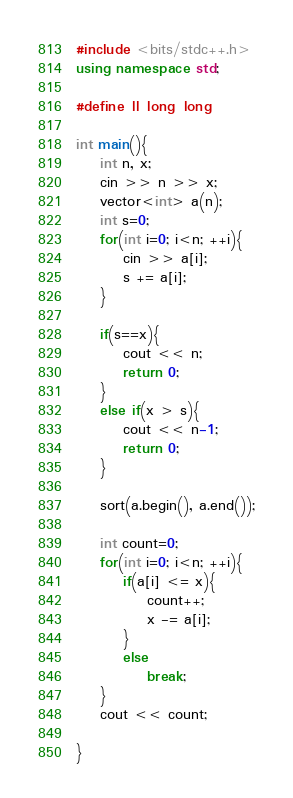Convert code to text. <code><loc_0><loc_0><loc_500><loc_500><_C++_>#include <bits/stdc++.h>
using namespace std;

#define ll long long

int main(){
    int n, x;
    cin >> n >> x;
    vector<int> a(n);
    int s=0;
    for(int i=0; i<n; ++i){
        cin >> a[i];
        s += a[i];
    }
    
    if(s==x){
        cout << n;
        return 0;
    }
    else if(x > s){
        cout << n-1;
        return 0;
    }

    sort(a.begin(), a.end());

    int count=0;
    for(int i=0; i<n; ++i){
        if(a[i] <= x){
            count++;
            x -= a[i];
        }
        else
            break;
    }
    cout << count;

}
</code> 